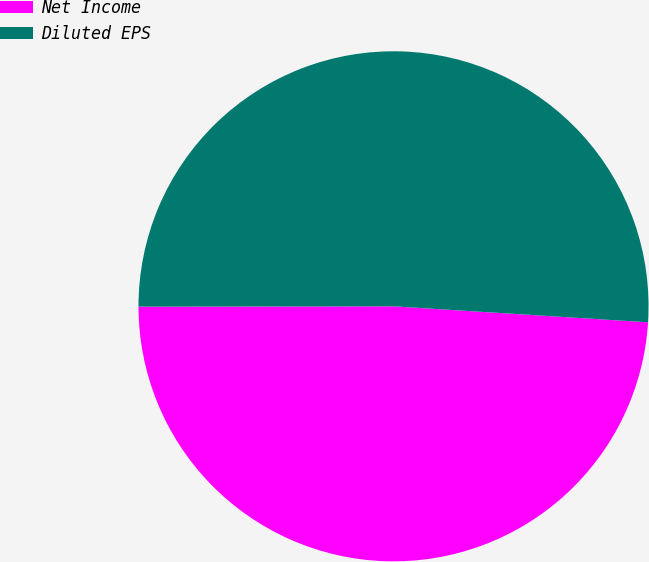<chart> <loc_0><loc_0><loc_500><loc_500><pie_chart><fcel>Net Income<fcel>Diluted EPS<nl><fcel>48.98%<fcel>51.02%<nl></chart> 